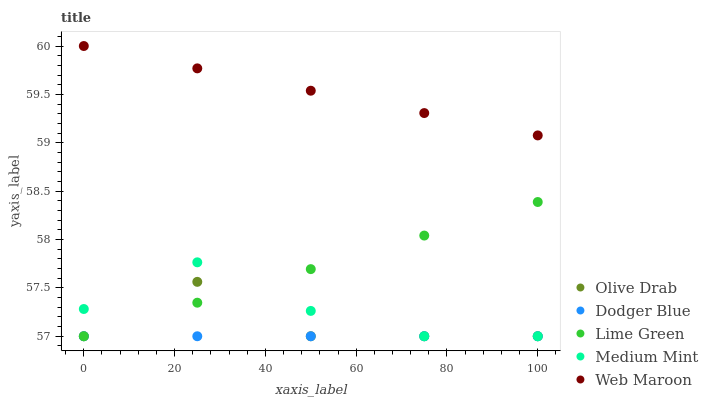Does Dodger Blue have the minimum area under the curve?
Answer yes or no. Yes. Does Web Maroon have the maximum area under the curve?
Answer yes or no. Yes. Does Lime Green have the minimum area under the curve?
Answer yes or no. No. Does Lime Green have the maximum area under the curve?
Answer yes or no. No. Is Dodger Blue the smoothest?
Answer yes or no. Yes. Is Olive Drab the roughest?
Answer yes or no. Yes. Is Lime Green the smoothest?
Answer yes or no. No. Is Lime Green the roughest?
Answer yes or no. No. Does Medium Mint have the lowest value?
Answer yes or no. Yes. Does Web Maroon have the lowest value?
Answer yes or no. No. Does Web Maroon have the highest value?
Answer yes or no. Yes. Does Lime Green have the highest value?
Answer yes or no. No. Is Dodger Blue less than Web Maroon?
Answer yes or no. Yes. Is Web Maroon greater than Medium Mint?
Answer yes or no. Yes. Does Lime Green intersect Dodger Blue?
Answer yes or no. Yes. Is Lime Green less than Dodger Blue?
Answer yes or no. No. Is Lime Green greater than Dodger Blue?
Answer yes or no. No. Does Dodger Blue intersect Web Maroon?
Answer yes or no. No. 